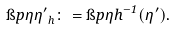<formula> <loc_0><loc_0><loc_500><loc_500>\i p { \eta } { \eta ^ { \prime } } _ { h } \colon = \i p { \eta } { h ^ { - 1 } ( \eta ^ { \prime } ) } .</formula> 